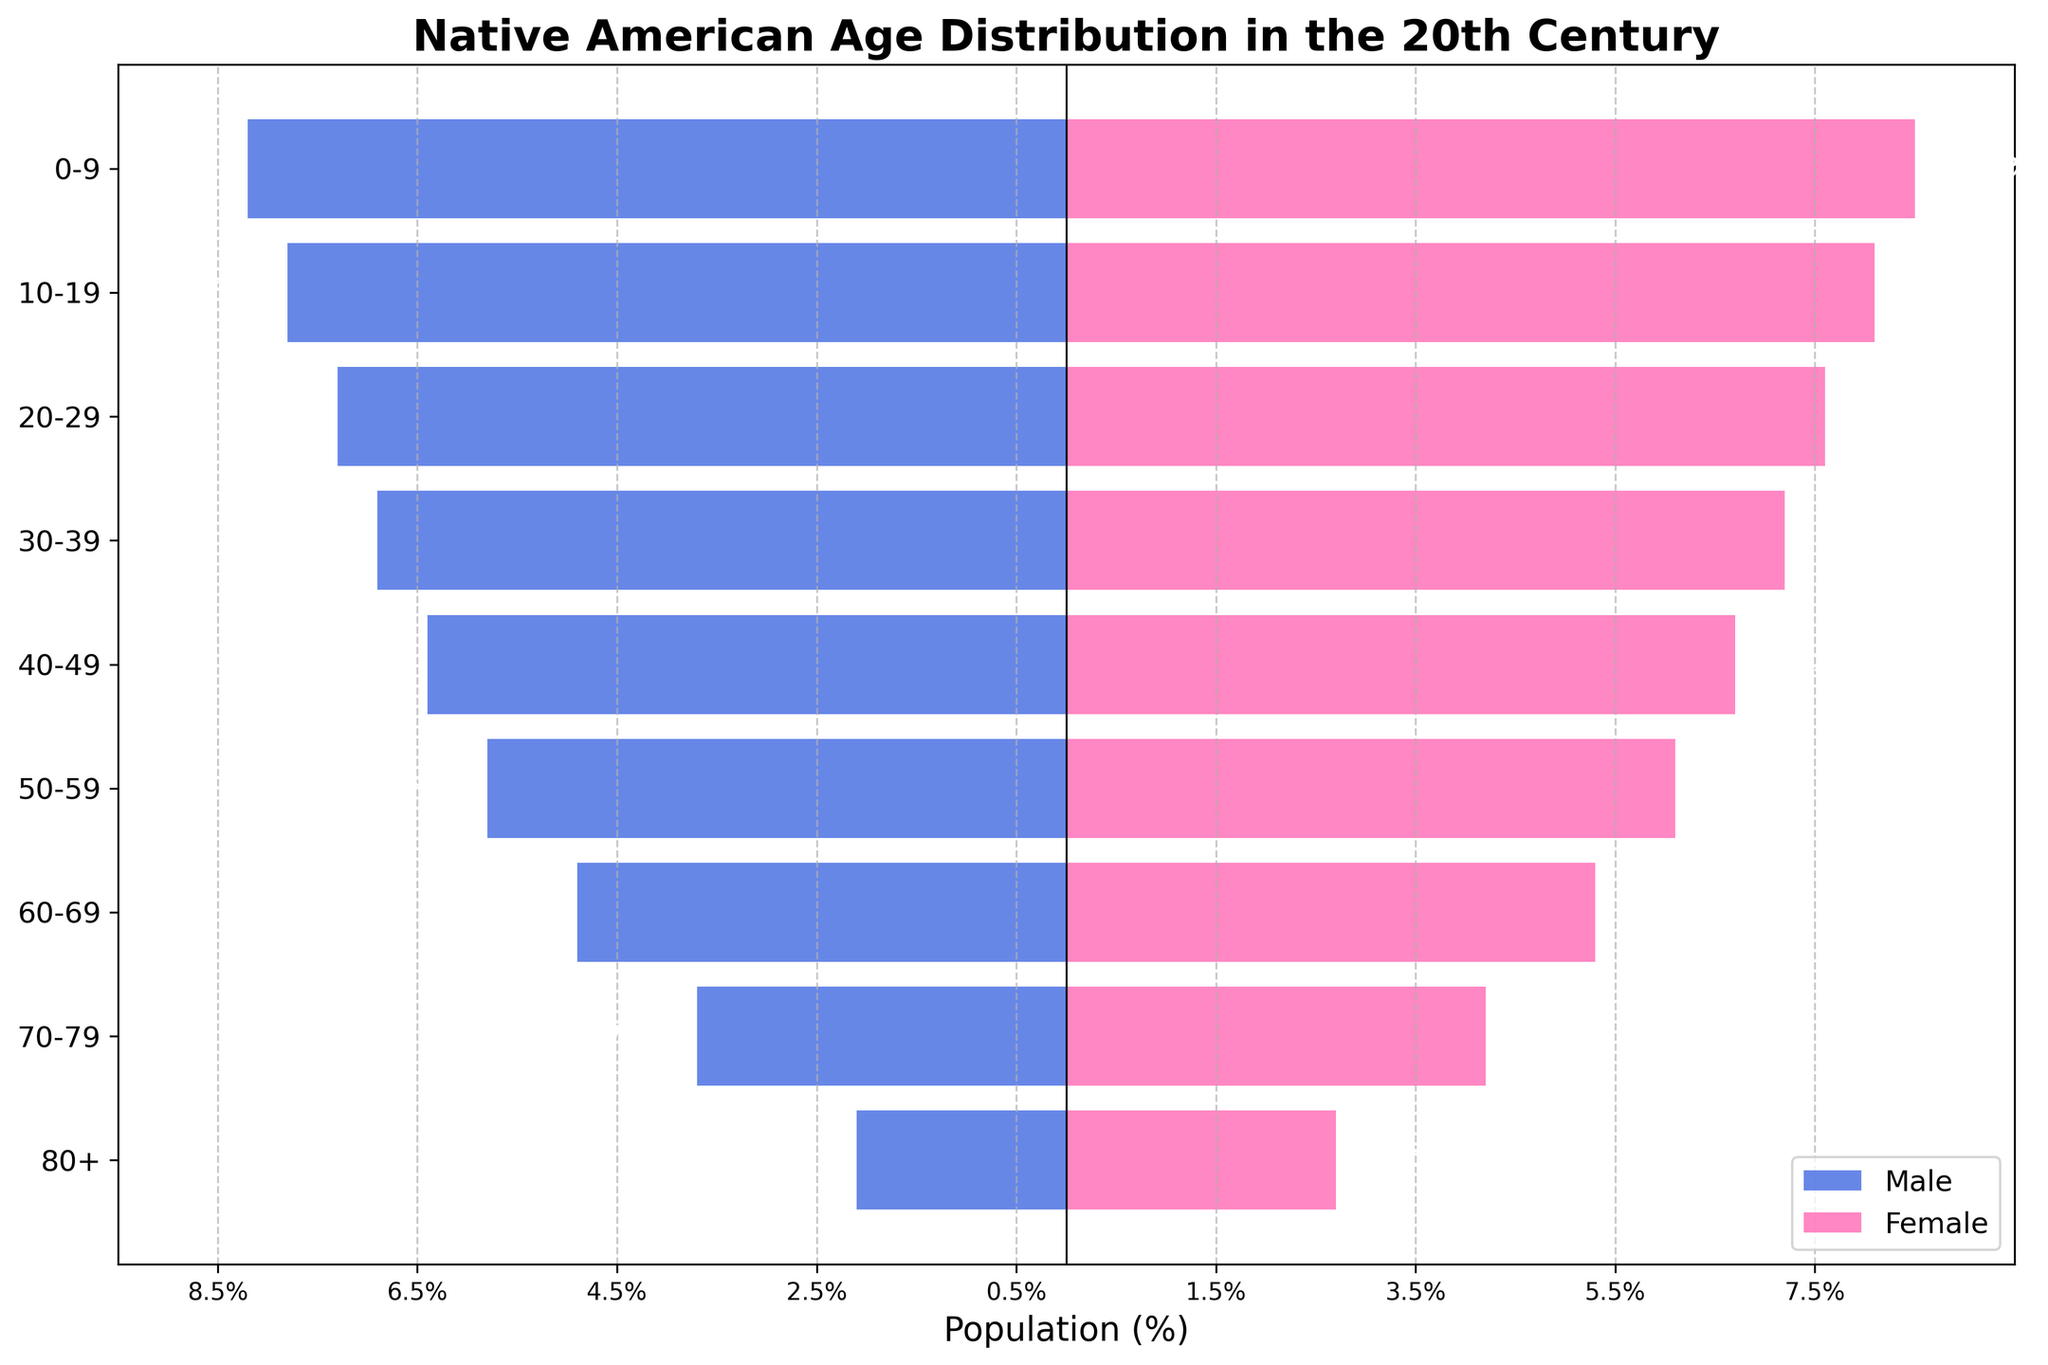What's the title of the plot? The title of the plot is written at the top and reads "Native American Age Distribution in the 20th Century".
Answer: Native American Age Distribution in the 20th Century How many age groups are represented in the population pyramid? The figure has the age groups listed vertically on the y-axis. Counting them, there are 9 age groups: 0-9, 10-19, 20-29, 30-39, 40-49, 50-59, 60-69, 70-79, and 80+.
Answer: 9 Which age group has the highest proportion of females? From the visualization, the age group with the widest pink bar (representing females) is the 0-9 age group.
Answer: 0-9 What is the population percentage of males aged 70-79? The bar for males in the 70-79 age group reaches -3.7%, indicating that 3.7% of the male population is in this age group.
Answer: 3.7% How does the population percentage of males aged 20-29 compare to that of females in the same age group? The male bar for the 20-29 age group shows -7.3%, while the female bar for the same age group shows 7.6%. Thus, 7.3% of males and 7.6% of females are in the 20-29 age group, with females having a slightly higher percentage.
Answer: Females have a slightly higher percentage What is the combined population percentage of males and females aged 60-69? Adding the values from the bars for the 60-69 age group: males (-4.9%) and females (5.3%). The combined value is 4.9% + 5.3% = 10.2%.
Answer: 10.2% Which gender has a higher population percentage in the oldest age group (80+)? For the age group 80+, the female bar is wider than the male bar, showing 2.7% for females and 2.1% for males.
Answer: Females In which age groups do females consistently outnumber males? By comparing the lengths of the bars for each age group, females consistently have a higher population percentage than males across all age groups displayed.
Answer: All age groups How does the pattern of population distribution change with increasing age? Provide a detailed explanation. Reviewing the plot, for younger age groups, the population percentages are higher for both genders. As the age groups increase, the population percentages decrease gradually. Starting from 0-9 with males at 8.2% and females at 8.5%, it continues decreasing to the 80+ age group with males at 2.1% and females at 2.7%. This indicates a larger proportion of younger individuals and a decreasing number of individuals as age increases, a common demographic pattern.
Answer: The population percentages decrease with increasing age 